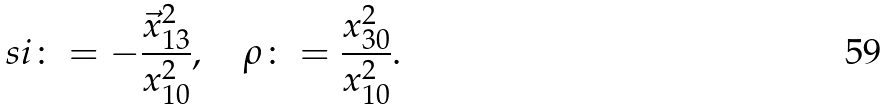Convert formula to latex. <formula><loc_0><loc_0><loc_500><loc_500>\ s i \colon = - \frac { \vec { x } _ { 1 3 } ^ { 2 } } { x _ { 1 0 } ^ { 2 } } , \quad \rho \colon = \frac { x _ { 3 0 } ^ { 2 } } { x _ { 1 0 } ^ { 2 } } .</formula> 